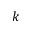Convert formula to latex. <formula><loc_0><loc_0><loc_500><loc_500>k</formula> 